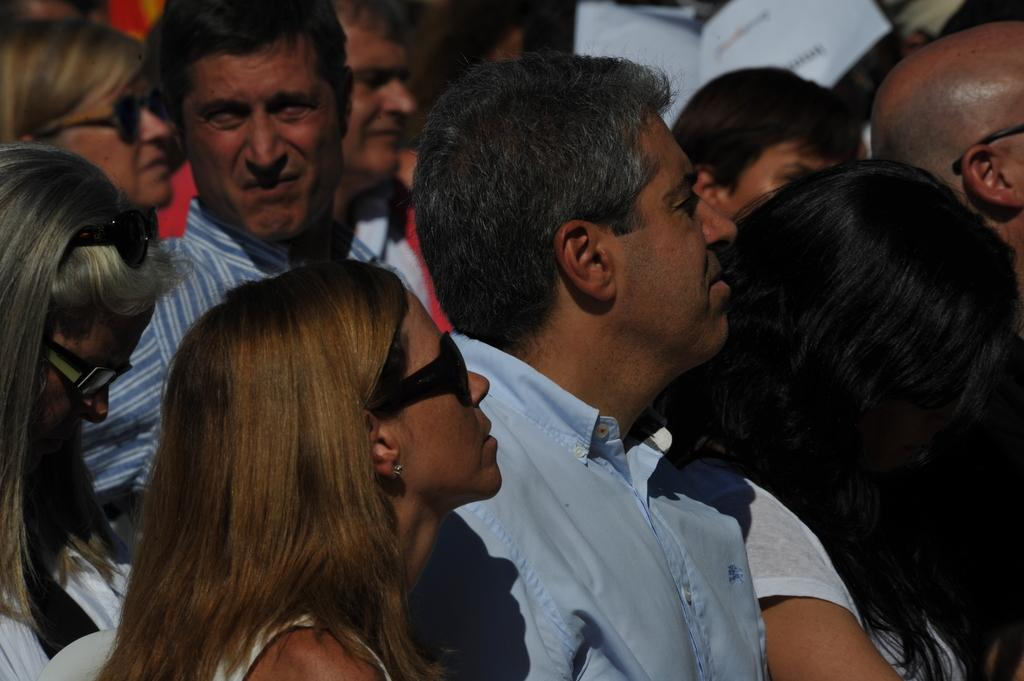What is the woman in the image wearing on her face? The woman in the image is wearing spectacles. What is the person wearing on the upper part of their body? The person is wearing a blue shirt. What is the woman on the left side of the image wearing on her face? The woman on the left side of the image is wearing goggles. Can you describe the people visible in the background of the image? There are other persons visible in the background of the image, but their specific features are not mentioned in the provided facts. What type of powder is being used to decorate the cake in the image? There is no cake or powder present in the image. What is the aftermath of the event depicted in the image? The provided facts do not mention any event or aftermath, so it cannot be determined from the image. 